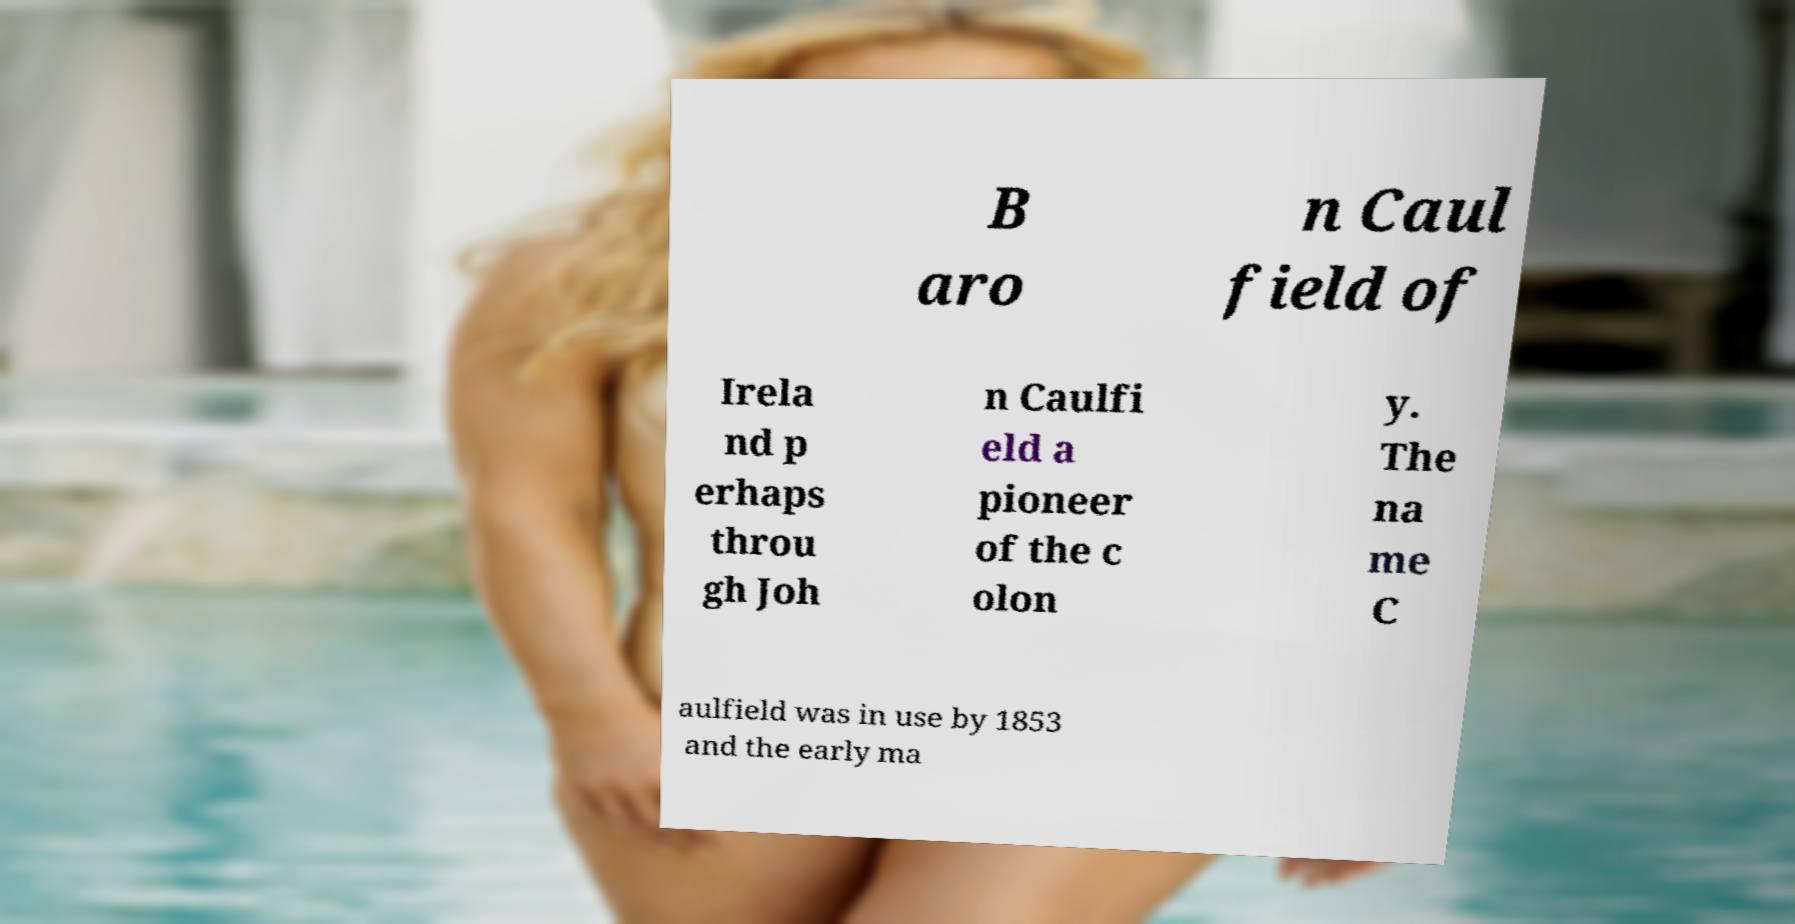Could you extract and type out the text from this image? B aro n Caul field of Irela nd p erhaps throu gh Joh n Caulfi eld a pioneer of the c olon y. The na me C aulfield was in use by 1853 and the early ma 